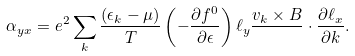Convert formula to latex. <formula><loc_0><loc_0><loc_500><loc_500>\alpha _ { y x } = e ^ { 2 } \sum _ { k } \frac { ( \epsilon _ { k } - \mu ) } { T } \left ( - \frac { \partial f ^ { 0 } } { \partial \epsilon } \right ) \ell _ { y } \frac { v _ { k } \times B } { } \cdot \frac { \partial \ell _ { x } } { \partial { k } } .</formula> 